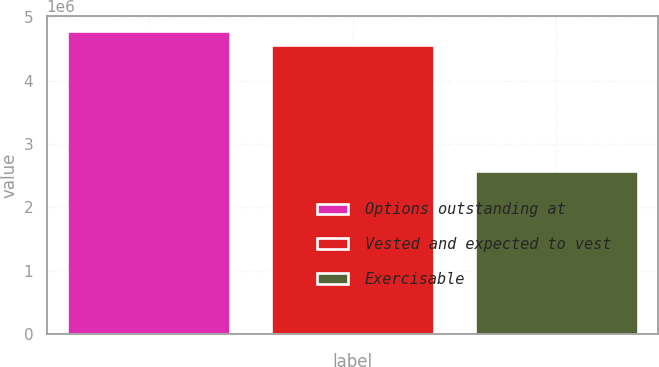Convert chart to OTSL. <chart><loc_0><loc_0><loc_500><loc_500><bar_chart><fcel>Options outstanding at<fcel>Vested and expected to vest<fcel>Exercisable<nl><fcel>4.7792e+06<fcel>4.5629e+06<fcel>2.5822e+06<nl></chart> 